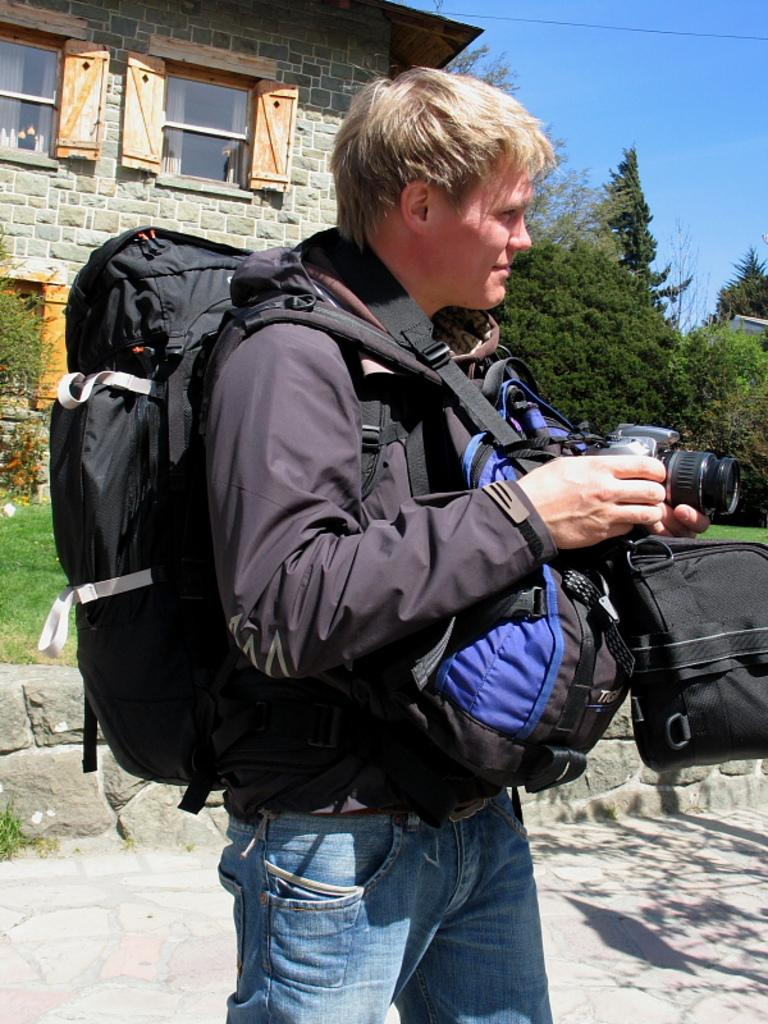What is the main subject of the image? There is a man in the image. What is the man wearing? The man is wearing bags. What is the man holding in his hands? The man is holding a camera in his hands. What can be seen in the background of the image? There is a building, windows, trees, and the sky visible in the background. How much tax is the man paying for the tray in the image? There is no tray present in the image, and therefore no tax can be associated with it. 